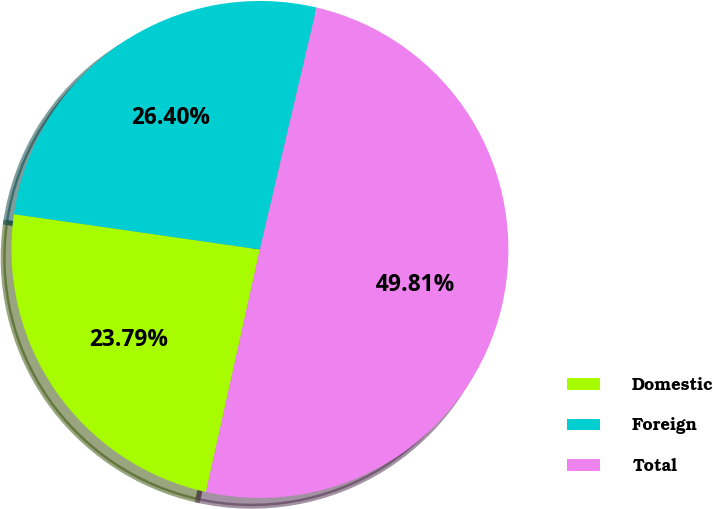Convert chart. <chart><loc_0><loc_0><loc_500><loc_500><pie_chart><fcel>Domestic<fcel>Foreign<fcel>Total<nl><fcel>23.79%<fcel>26.4%<fcel>49.81%<nl></chart> 